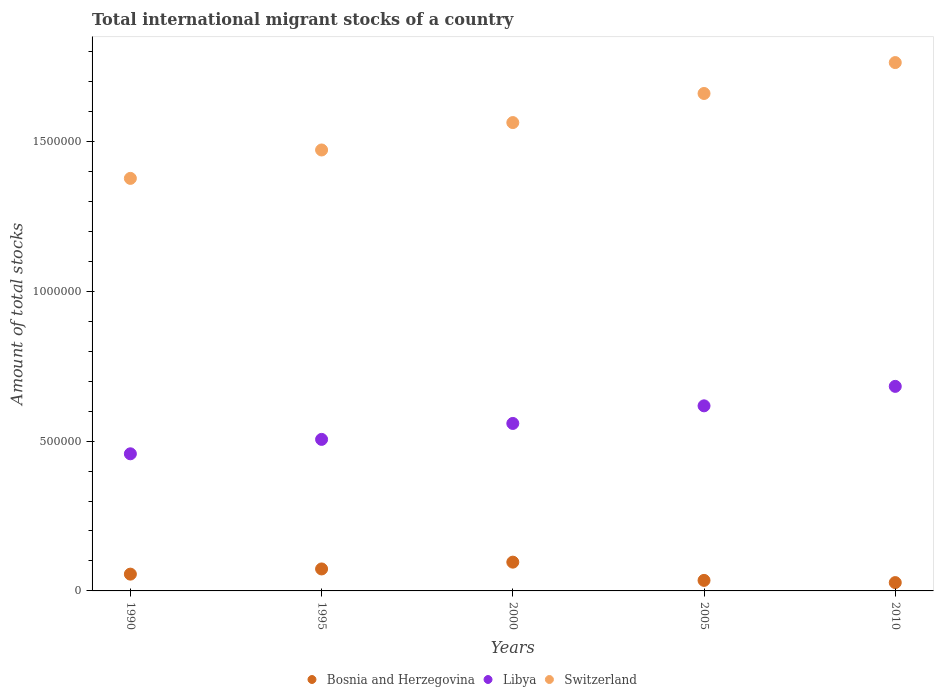Is the number of dotlines equal to the number of legend labels?
Make the answer very short. Yes. What is the amount of total stocks in in Bosnia and Herzegovina in 2005?
Provide a succinct answer. 3.51e+04. Across all years, what is the maximum amount of total stocks in in Switzerland?
Offer a very short reply. 1.76e+06. Across all years, what is the minimum amount of total stocks in in Switzerland?
Offer a very short reply. 1.38e+06. What is the total amount of total stocks in in Bosnia and Herzegovina in the graph?
Offer a terse response. 2.88e+05. What is the difference between the amount of total stocks in in Bosnia and Herzegovina in 2000 and that in 2010?
Give a very brief answer. 6.82e+04. What is the difference between the amount of total stocks in in Switzerland in 1995 and the amount of total stocks in in Bosnia and Herzegovina in 2000?
Your answer should be very brief. 1.38e+06. What is the average amount of total stocks in in Bosnia and Herzegovina per year?
Your answer should be compact. 5.76e+04. In the year 2010, what is the difference between the amount of total stocks in in Libya and amount of total stocks in in Switzerland?
Provide a short and direct response. -1.08e+06. What is the ratio of the amount of total stocks in in Bosnia and Herzegovina in 1990 to that in 2010?
Your answer should be compact. 2.02. Is the amount of total stocks in in Switzerland in 2000 less than that in 2005?
Your answer should be compact. Yes. What is the difference between the highest and the second highest amount of total stocks in in Bosnia and Herzegovina?
Give a very brief answer. 2.27e+04. What is the difference between the highest and the lowest amount of total stocks in in Bosnia and Herzegovina?
Give a very brief answer. 6.82e+04. In how many years, is the amount of total stocks in in Libya greater than the average amount of total stocks in in Libya taken over all years?
Give a very brief answer. 2. Is the amount of total stocks in in Bosnia and Herzegovina strictly less than the amount of total stocks in in Libya over the years?
Your answer should be very brief. Yes. How many dotlines are there?
Your answer should be compact. 3. Does the graph contain any zero values?
Provide a short and direct response. No. What is the title of the graph?
Make the answer very short. Total international migrant stocks of a country. What is the label or title of the X-axis?
Give a very brief answer. Years. What is the label or title of the Y-axis?
Keep it short and to the point. Amount of total stocks. What is the Amount of total stocks in Bosnia and Herzegovina in 1990?
Your response must be concise. 5.60e+04. What is the Amount of total stocks in Libya in 1990?
Offer a very short reply. 4.57e+05. What is the Amount of total stocks of Switzerland in 1990?
Provide a succinct answer. 1.38e+06. What is the Amount of total stocks in Bosnia and Herzegovina in 1995?
Your answer should be compact. 7.33e+04. What is the Amount of total stocks of Libya in 1995?
Offer a very short reply. 5.06e+05. What is the Amount of total stocks in Switzerland in 1995?
Make the answer very short. 1.47e+06. What is the Amount of total stocks in Bosnia and Herzegovina in 2000?
Offer a terse response. 9.60e+04. What is the Amount of total stocks in Libya in 2000?
Give a very brief answer. 5.59e+05. What is the Amount of total stocks in Switzerland in 2000?
Give a very brief answer. 1.56e+06. What is the Amount of total stocks of Bosnia and Herzegovina in 2005?
Offer a terse response. 3.51e+04. What is the Amount of total stocks of Libya in 2005?
Provide a succinct answer. 6.18e+05. What is the Amount of total stocks in Switzerland in 2005?
Offer a very short reply. 1.66e+06. What is the Amount of total stocks in Bosnia and Herzegovina in 2010?
Your response must be concise. 2.78e+04. What is the Amount of total stocks of Libya in 2010?
Make the answer very short. 6.82e+05. What is the Amount of total stocks in Switzerland in 2010?
Make the answer very short. 1.76e+06. Across all years, what is the maximum Amount of total stocks of Bosnia and Herzegovina?
Your answer should be compact. 9.60e+04. Across all years, what is the maximum Amount of total stocks of Libya?
Your response must be concise. 6.82e+05. Across all years, what is the maximum Amount of total stocks of Switzerland?
Keep it short and to the point. 1.76e+06. Across all years, what is the minimum Amount of total stocks of Bosnia and Herzegovina?
Your response must be concise. 2.78e+04. Across all years, what is the minimum Amount of total stocks in Libya?
Ensure brevity in your answer.  4.57e+05. Across all years, what is the minimum Amount of total stocks in Switzerland?
Your answer should be very brief. 1.38e+06. What is the total Amount of total stocks of Bosnia and Herzegovina in the graph?
Offer a terse response. 2.88e+05. What is the total Amount of total stocks in Libya in the graph?
Your answer should be very brief. 2.82e+06. What is the total Amount of total stocks of Switzerland in the graph?
Offer a terse response. 7.83e+06. What is the difference between the Amount of total stocks of Bosnia and Herzegovina in 1990 and that in 1995?
Keep it short and to the point. -1.73e+04. What is the difference between the Amount of total stocks in Libya in 1990 and that in 1995?
Provide a short and direct response. -4.81e+04. What is the difference between the Amount of total stocks of Switzerland in 1990 and that in 1995?
Keep it short and to the point. -9.48e+04. What is the difference between the Amount of total stocks of Bosnia and Herzegovina in 1990 and that in 2000?
Offer a very short reply. -4.00e+04. What is the difference between the Amount of total stocks in Libya in 1990 and that in 2000?
Keep it short and to the point. -1.01e+05. What is the difference between the Amount of total stocks of Switzerland in 1990 and that in 2000?
Keep it short and to the point. -1.86e+05. What is the difference between the Amount of total stocks of Bosnia and Herzegovina in 1990 and that in 2005?
Give a very brief answer. 2.09e+04. What is the difference between the Amount of total stocks in Libya in 1990 and that in 2005?
Offer a terse response. -1.60e+05. What is the difference between the Amount of total stocks in Switzerland in 1990 and that in 2005?
Keep it short and to the point. -2.83e+05. What is the difference between the Amount of total stocks of Bosnia and Herzegovina in 1990 and that in 2010?
Make the answer very short. 2.82e+04. What is the difference between the Amount of total stocks in Libya in 1990 and that in 2010?
Provide a succinct answer. -2.25e+05. What is the difference between the Amount of total stocks of Switzerland in 1990 and that in 2010?
Offer a terse response. -3.86e+05. What is the difference between the Amount of total stocks in Bosnia and Herzegovina in 1995 and that in 2000?
Keep it short and to the point. -2.27e+04. What is the difference between the Amount of total stocks of Libya in 1995 and that in 2000?
Your response must be concise. -5.32e+04. What is the difference between the Amount of total stocks of Switzerland in 1995 and that in 2000?
Offer a terse response. -9.14e+04. What is the difference between the Amount of total stocks of Bosnia and Herzegovina in 1995 and that in 2005?
Keep it short and to the point. 3.82e+04. What is the difference between the Amount of total stocks of Libya in 1995 and that in 2005?
Offer a terse response. -1.12e+05. What is the difference between the Amount of total stocks in Switzerland in 1995 and that in 2005?
Offer a terse response. -1.88e+05. What is the difference between the Amount of total stocks in Bosnia and Herzegovina in 1995 and that in 2010?
Ensure brevity in your answer.  4.55e+04. What is the difference between the Amount of total stocks of Libya in 1995 and that in 2010?
Provide a short and direct response. -1.77e+05. What is the difference between the Amount of total stocks of Switzerland in 1995 and that in 2010?
Give a very brief answer. -2.92e+05. What is the difference between the Amount of total stocks of Bosnia and Herzegovina in 2000 and that in 2005?
Provide a short and direct response. 6.09e+04. What is the difference between the Amount of total stocks in Libya in 2000 and that in 2005?
Give a very brief answer. -5.88e+04. What is the difference between the Amount of total stocks of Switzerland in 2000 and that in 2005?
Provide a short and direct response. -9.71e+04. What is the difference between the Amount of total stocks of Bosnia and Herzegovina in 2000 and that in 2010?
Your answer should be very brief. 6.82e+04. What is the difference between the Amount of total stocks in Libya in 2000 and that in 2010?
Give a very brief answer. -1.24e+05. What is the difference between the Amount of total stocks of Switzerland in 2000 and that in 2010?
Ensure brevity in your answer.  -2.00e+05. What is the difference between the Amount of total stocks of Bosnia and Herzegovina in 2005 and that in 2010?
Provide a short and direct response. 7361. What is the difference between the Amount of total stocks in Libya in 2005 and that in 2010?
Provide a short and direct response. -6.49e+04. What is the difference between the Amount of total stocks of Switzerland in 2005 and that in 2010?
Ensure brevity in your answer.  -1.03e+05. What is the difference between the Amount of total stocks of Bosnia and Herzegovina in 1990 and the Amount of total stocks of Libya in 1995?
Offer a terse response. -4.50e+05. What is the difference between the Amount of total stocks in Bosnia and Herzegovina in 1990 and the Amount of total stocks in Switzerland in 1995?
Give a very brief answer. -1.42e+06. What is the difference between the Amount of total stocks in Libya in 1990 and the Amount of total stocks in Switzerland in 1995?
Ensure brevity in your answer.  -1.01e+06. What is the difference between the Amount of total stocks in Bosnia and Herzegovina in 1990 and the Amount of total stocks in Libya in 2000?
Make the answer very short. -5.03e+05. What is the difference between the Amount of total stocks of Bosnia and Herzegovina in 1990 and the Amount of total stocks of Switzerland in 2000?
Keep it short and to the point. -1.51e+06. What is the difference between the Amount of total stocks of Libya in 1990 and the Amount of total stocks of Switzerland in 2000?
Your response must be concise. -1.11e+06. What is the difference between the Amount of total stocks in Bosnia and Herzegovina in 1990 and the Amount of total stocks in Libya in 2005?
Give a very brief answer. -5.62e+05. What is the difference between the Amount of total stocks of Bosnia and Herzegovina in 1990 and the Amount of total stocks of Switzerland in 2005?
Ensure brevity in your answer.  -1.60e+06. What is the difference between the Amount of total stocks of Libya in 1990 and the Amount of total stocks of Switzerland in 2005?
Offer a very short reply. -1.20e+06. What is the difference between the Amount of total stocks in Bosnia and Herzegovina in 1990 and the Amount of total stocks in Libya in 2010?
Give a very brief answer. -6.26e+05. What is the difference between the Amount of total stocks in Bosnia and Herzegovina in 1990 and the Amount of total stocks in Switzerland in 2010?
Give a very brief answer. -1.71e+06. What is the difference between the Amount of total stocks of Libya in 1990 and the Amount of total stocks of Switzerland in 2010?
Offer a terse response. -1.31e+06. What is the difference between the Amount of total stocks of Bosnia and Herzegovina in 1995 and the Amount of total stocks of Libya in 2000?
Give a very brief answer. -4.85e+05. What is the difference between the Amount of total stocks of Bosnia and Herzegovina in 1995 and the Amount of total stocks of Switzerland in 2000?
Keep it short and to the point. -1.49e+06. What is the difference between the Amount of total stocks in Libya in 1995 and the Amount of total stocks in Switzerland in 2000?
Offer a terse response. -1.06e+06. What is the difference between the Amount of total stocks in Bosnia and Herzegovina in 1995 and the Amount of total stocks in Libya in 2005?
Offer a very short reply. -5.44e+05. What is the difference between the Amount of total stocks of Bosnia and Herzegovina in 1995 and the Amount of total stocks of Switzerland in 2005?
Provide a short and direct response. -1.59e+06. What is the difference between the Amount of total stocks of Libya in 1995 and the Amount of total stocks of Switzerland in 2005?
Make the answer very short. -1.15e+06. What is the difference between the Amount of total stocks of Bosnia and Herzegovina in 1995 and the Amount of total stocks of Libya in 2010?
Your response must be concise. -6.09e+05. What is the difference between the Amount of total stocks of Bosnia and Herzegovina in 1995 and the Amount of total stocks of Switzerland in 2010?
Make the answer very short. -1.69e+06. What is the difference between the Amount of total stocks in Libya in 1995 and the Amount of total stocks in Switzerland in 2010?
Your answer should be compact. -1.26e+06. What is the difference between the Amount of total stocks in Bosnia and Herzegovina in 2000 and the Amount of total stocks in Libya in 2005?
Provide a short and direct response. -5.22e+05. What is the difference between the Amount of total stocks of Bosnia and Herzegovina in 2000 and the Amount of total stocks of Switzerland in 2005?
Keep it short and to the point. -1.56e+06. What is the difference between the Amount of total stocks in Libya in 2000 and the Amount of total stocks in Switzerland in 2005?
Provide a short and direct response. -1.10e+06. What is the difference between the Amount of total stocks of Bosnia and Herzegovina in 2000 and the Amount of total stocks of Libya in 2010?
Provide a short and direct response. -5.86e+05. What is the difference between the Amount of total stocks in Bosnia and Herzegovina in 2000 and the Amount of total stocks in Switzerland in 2010?
Ensure brevity in your answer.  -1.67e+06. What is the difference between the Amount of total stocks of Libya in 2000 and the Amount of total stocks of Switzerland in 2010?
Offer a terse response. -1.20e+06. What is the difference between the Amount of total stocks in Bosnia and Herzegovina in 2005 and the Amount of total stocks in Libya in 2010?
Your answer should be compact. -6.47e+05. What is the difference between the Amount of total stocks of Bosnia and Herzegovina in 2005 and the Amount of total stocks of Switzerland in 2010?
Provide a succinct answer. -1.73e+06. What is the difference between the Amount of total stocks of Libya in 2005 and the Amount of total stocks of Switzerland in 2010?
Provide a succinct answer. -1.15e+06. What is the average Amount of total stocks in Bosnia and Herzegovina per year?
Your answer should be very brief. 5.76e+04. What is the average Amount of total stocks in Libya per year?
Your answer should be very brief. 5.64e+05. What is the average Amount of total stocks in Switzerland per year?
Provide a short and direct response. 1.57e+06. In the year 1990, what is the difference between the Amount of total stocks in Bosnia and Herzegovina and Amount of total stocks in Libya?
Your answer should be compact. -4.01e+05. In the year 1990, what is the difference between the Amount of total stocks in Bosnia and Herzegovina and Amount of total stocks in Switzerland?
Your answer should be compact. -1.32e+06. In the year 1990, what is the difference between the Amount of total stocks of Libya and Amount of total stocks of Switzerland?
Offer a very short reply. -9.19e+05. In the year 1995, what is the difference between the Amount of total stocks in Bosnia and Herzegovina and Amount of total stocks in Libya?
Your answer should be very brief. -4.32e+05. In the year 1995, what is the difference between the Amount of total stocks of Bosnia and Herzegovina and Amount of total stocks of Switzerland?
Provide a short and direct response. -1.40e+06. In the year 1995, what is the difference between the Amount of total stocks of Libya and Amount of total stocks of Switzerland?
Make the answer very short. -9.66e+05. In the year 2000, what is the difference between the Amount of total stocks in Bosnia and Herzegovina and Amount of total stocks in Libya?
Offer a very short reply. -4.63e+05. In the year 2000, what is the difference between the Amount of total stocks in Bosnia and Herzegovina and Amount of total stocks in Switzerland?
Keep it short and to the point. -1.47e+06. In the year 2000, what is the difference between the Amount of total stocks in Libya and Amount of total stocks in Switzerland?
Provide a short and direct response. -1.00e+06. In the year 2005, what is the difference between the Amount of total stocks in Bosnia and Herzegovina and Amount of total stocks in Libya?
Provide a short and direct response. -5.82e+05. In the year 2005, what is the difference between the Amount of total stocks in Bosnia and Herzegovina and Amount of total stocks in Switzerland?
Your answer should be compact. -1.62e+06. In the year 2005, what is the difference between the Amount of total stocks of Libya and Amount of total stocks of Switzerland?
Offer a terse response. -1.04e+06. In the year 2010, what is the difference between the Amount of total stocks in Bosnia and Herzegovina and Amount of total stocks in Libya?
Your response must be concise. -6.55e+05. In the year 2010, what is the difference between the Amount of total stocks in Bosnia and Herzegovina and Amount of total stocks in Switzerland?
Make the answer very short. -1.74e+06. In the year 2010, what is the difference between the Amount of total stocks in Libya and Amount of total stocks in Switzerland?
Give a very brief answer. -1.08e+06. What is the ratio of the Amount of total stocks in Bosnia and Herzegovina in 1990 to that in 1995?
Your response must be concise. 0.76. What is the ratio of the Amount of total stocks of Libya in 1990 to that in 1995?
Provide a short and direct response. 0.9. What is the ratio of the Amount of total stocks in Switzerland in 1990 to that in 1995?
Offer a very short reply. 0.94. What is the ratio of the Amount of total stocks in Bosnia and Herzegovina in 1990 to that in 2000?
Give a very brief answer. 0.58. What is the ratio of the Amount of total stocks in Libya in 1990 to that in 2000?
Offer a very short reply. 0.82. What is the ratio of the Amount of total stocks of Switzerland in 1990 to that in 2000?
Give a very brief answer. 0.88. What is the ratio of the Amount of total stocks of Bosnia and Herzegovina in 1990 to that in 2005?
Provide a succinct answer. 1.59. What is the ratio of the Amount of total stocks of Libya in 1990 to that in 2005?
Give a very brief answer. 0.74. What is the ratio of the Amount of total stocks in Switzerland in 1990 to that in 2005?
Offer a very short reply. 0.83. What is the ratio of the Amount of total stocks in Bosnia and Herzegovina in 1990 to that in 2010?
Provide a short and direct response. 2.02. What is the ratio of the Amount of total stocks in Libya in 1990 to that in 2010?
Make the answer very short. 0.67. What is the ratio of the Amount of total stocks in Switzerland in 1990 to that in 2010?
Keep it short and to the point. 0.78. What is the ratio of the Amount of total stocks in Bosnia and Herzegovina in 1995 to that in 2000?
Give a very brief answer. 0.76. What is the ratio of the Amount of total stocks of Libya in 1995 to that in 2000?
Give a very brief answer. 0.9. What is the ratio of the Amount of total stocks of Switzerland in 1995 to that in 2000?
Keep it short and to the point. 0.94. What is the ratio of the Amount of total stocks in Bosnia and Herzegovina in 1995 to that in 2005?
Provide a short and direct response. 2.09. What is the ratio of the Amount of total stocks in Libya in 1995 to that in 2005?
Your answer should be very brief. 0.82. What is the ratio of the Amount of total stocks in Switzerland in 1995 to that in 2005?
Your answer should be compact. 0.89. What is the ratio of the Amount of total stocks of Bosnia and Herzegovina in 1995 to that in 2010?
Give a very brief answer. 2.64. What is the ratio of the Amount of total stocks of Libya in 1995 to that in 2010?
Offer a terse response. 0.74. What is the ratio of the Amount of total stocks of Switzerland in 1995 to that in 2010?
Provide a succinct answer. 0.83. What is the ratio of the Amount of total stocks of Bosnia and Herzegovina in 2000 to that in 2005?
Offer a terse response. 2.73. What is the ratio of the Amount of total stocks in Libya in 2000 to that in 2005?
Offer a very short reply. 0.9. What is the ratio of the Amount of total stocks in Switzerland in 2000 to that in 2005?
Keep it short and to the point. 0.94. What is the ratio of the Amount of total stocks in Bosnia and Herzegovina in 2000 to that in 2010?
Offer a terse response. 3.46. What is the ratio of the Amount of total stocks of Libya in 2000 to that in 2010?
Your answer should be very brief. 0.82. What is the ratio of the Amount of total stocks of Switzerland in 2000 to that in 2010?
Offer a terse response. 0.89. What is the ratio of the Amount of total stocks of Bosnia and Herzegovina in 2005 to that in 2010?
Give a very brief answer. 1.26. What is the ratio of the Amount of total stocks of Libya in 2005 to that in 2010?
Offer a very short reply. 0.9. What is the ratio of the Amount of total stocks in Switzerland in 2005 to that in 2010?
Offer a terse response. 0.94. What is the difference between the highest and the second highest Amount of total stocks in Bosnia and Herzegovina?
Your answer should be compact. 2.27e+04. What is the difference between the highest and the second highest Amount of total stocks of Libya?
Your answer should be compact. 6.49e+04. What is the difference between the highest and the second highest Amount of total stocks in Switzerland?
Offer a terse response. 1.03e+05. What is the difference between the highest and the lowest Amount of total stocks in Bosnia and Herzegovina?
Keep it short and to the point. 6.82e+04. What is the difference between the highest and the lowest Amount of total stocks of Libya?
Offer a terse response. 2.25e+05. What is the difference between the highest and the lowest Amount of total stocks of Switzerland?
Offer a very short reply. 3.86e+05. 